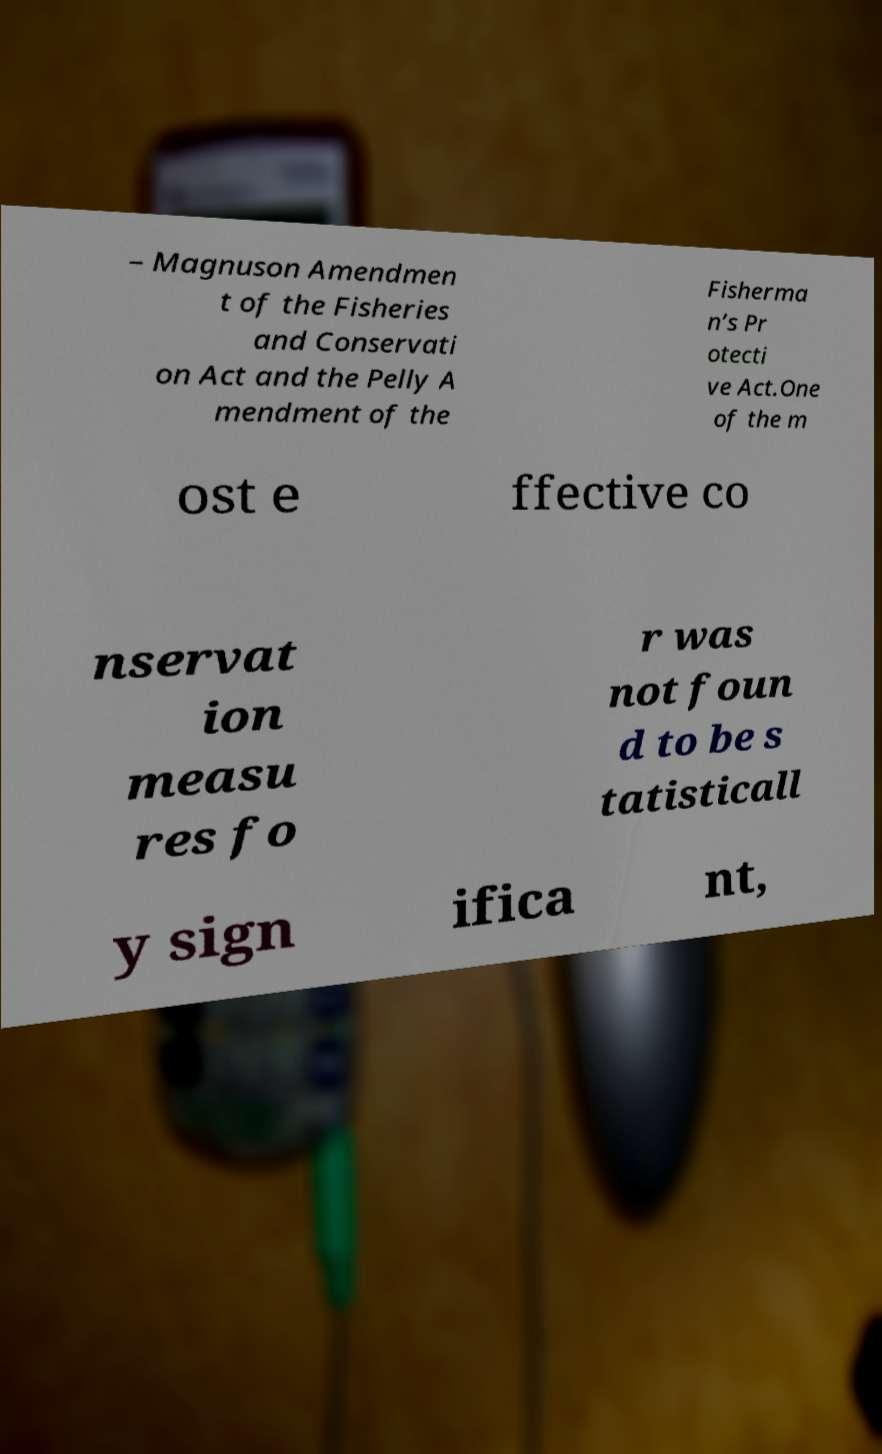Could you extract and type out the text from this image? – Magnuson Amendmen t of the Fisheries and Conservati on Act and the Pelly A mendment of the Fisherma n’s Pr otecti ve Act.One of the m ost e ffective co nservat ion measu res fo r was not foun d to be s tatisticall y sign ifica nt, 